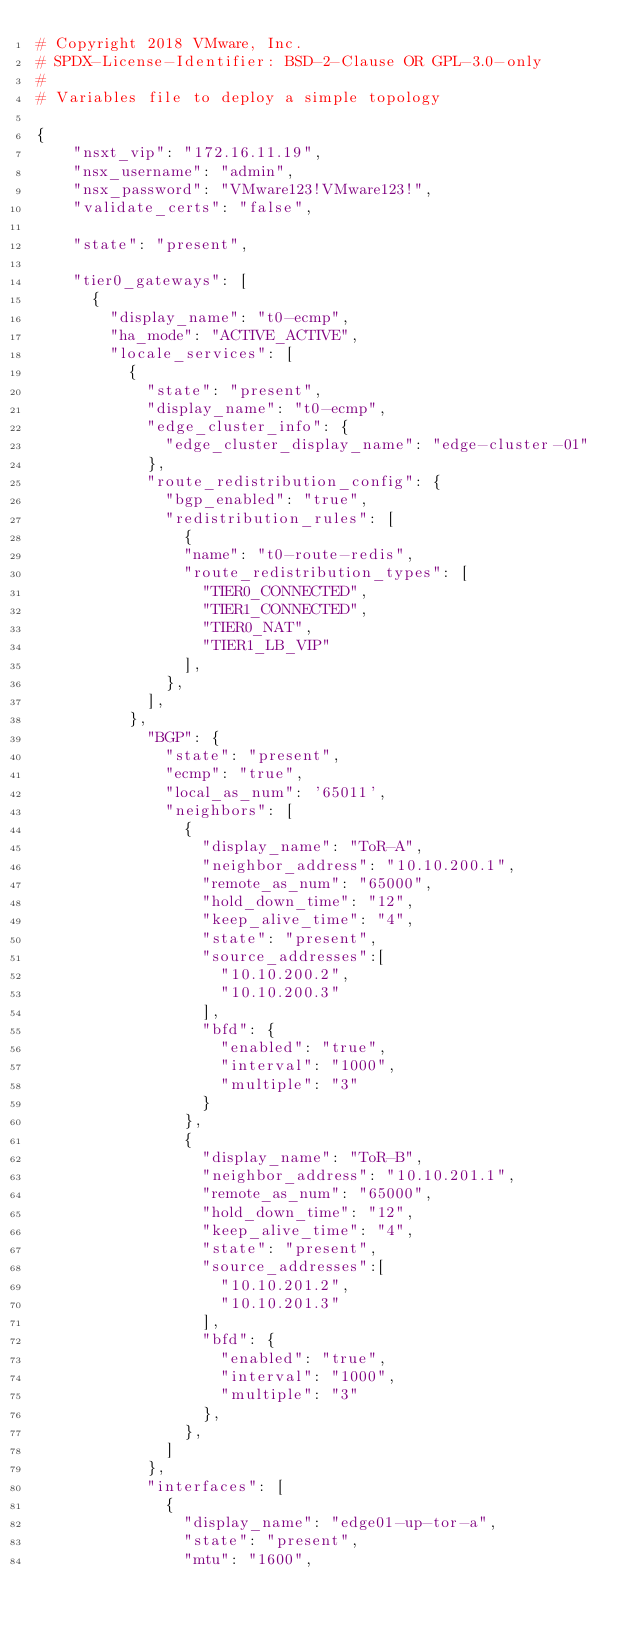Convert code to text. <code><loc_0><loc_0><loc_500><loc_500><_YAML_># Copyright 2018 VMware, Inc.
# SPDX-License-Identifier: BSD-2-Clause OR GPL-3.0-only
#
# Variables file to deploy a simple topology

{
    "nsxt_vip": "172.16.11.19",
    "nsx_username": "admin",
    "nsx_password": "VMware123!VMware123!",
    "validate_certs": "false",

    "state": "present",

    "tier0_gateways": [
      {
        "display_name": "t0-ecmp",
        "ha_mode": "ACTIVE_ACTIVE",
        "locale_services": [
          {
            "state": "present",
            "display_name": "t0-ecmp",
            "edge_cluster_info": {
              "edge_cluster_display_name": "edge-cluster-01"
            },
            "route_redistribution_config": {
              "bgp_enabled": "true",
              "redistribution_rules": [
                {
                "name": "t0-route-redis",
                "route_redistribution_types": [
                  "TIER0_CONNECTED",
                  "TIER1_CONNECTED",
                  "TIER0_NAT",
                  "TIER1_LB_VIP"
                ],
              },
            ],
          },
            "BGP": {
              "state": "present",
              "ecmp": "true",
              "local_as_num": '65011',
              "neighbors": [
                {
                  "display_name": "ToR-A",
                  "neighbor_address": "10.10.200.1",
                  "remote_as_num": "65000",
                  "hold_down_time": "12",
                  "keep_alive_time": "4",
                  "state": "present",
                  "source_addresses":[
                    "10.10.200.2",
                    "10.10.200.3"
                  ],
                  "bfd": {
                    "enabled": "true",
                    "interval": "1000",
                    "multiple": "3"
                  }
                },
                {
                  "display_name": "ToR-B",
                  "neighbor_address": "10.10.201.1",
                  "remote_as_num": "65000",
                  "hold_down_time": "12",
                  "keep_alive_time": "4",
                  "state": "present",
                  "source_addresses":[
                    "10.10.201.2",
                    "10.10.201.3"
                  ],
                  "bfd": {
                    "enabled": "true",
                    "interval": "1000",
                    "multiple": "3"
                  },
                },                
              ]
            },
            "interfaces": [
              {
                "display_name": "edge01-up-tor-a",
                "state": "present",
                "mtu": "1600",</code> 